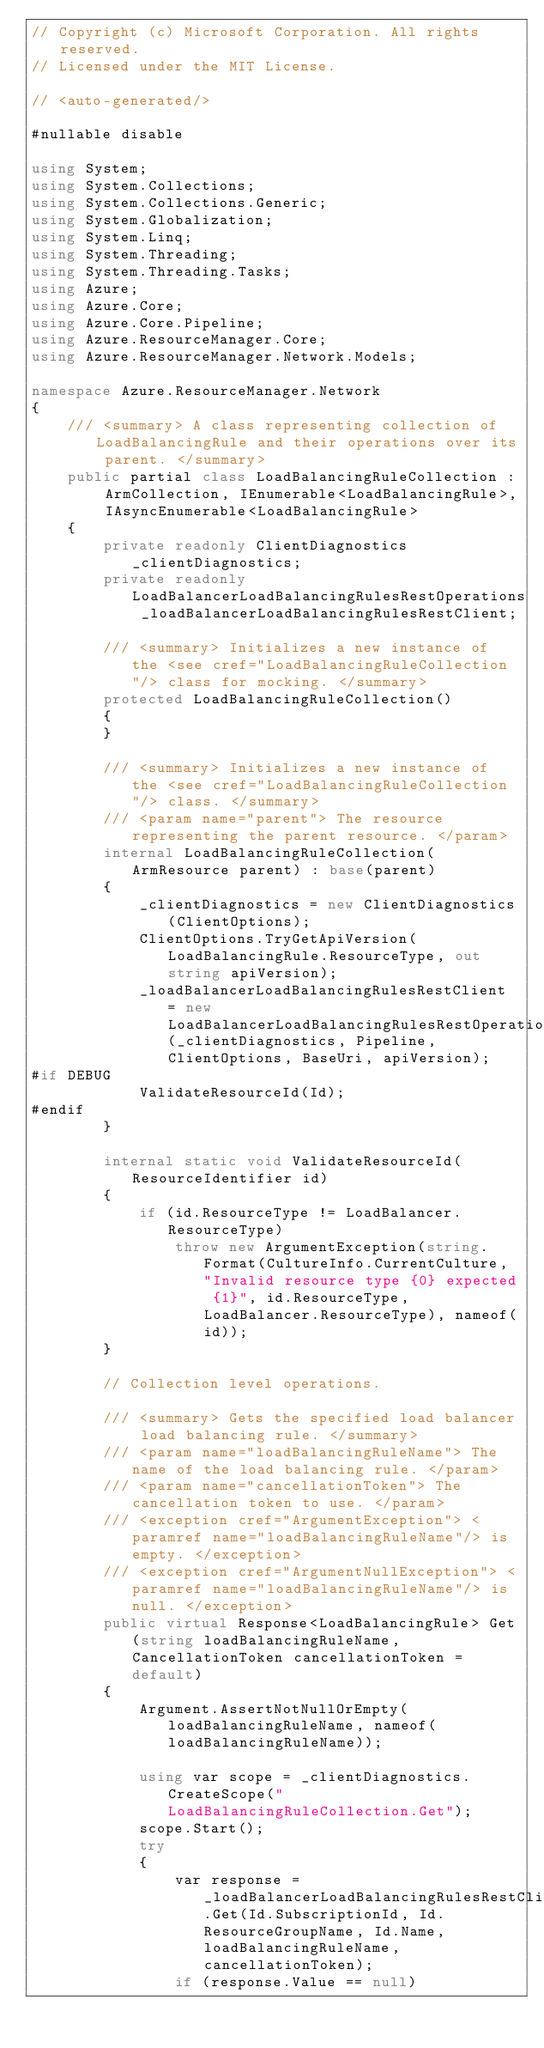<code> <loc_0><loc_0><loc_500><loc_500><_C#_>// Copyright (c) Microsoft Corporation. All rights reserved.
// Licensed under the MIT License.

// <auto-generated/>

#nullable disable

using System;
using System.Collections;
using System.Collections.Generic;
using System.Globalization;
using System.Linq;
using System.Threading;
using System.Threading.Tasks;
using Azure;
using Azure.Core;
using Azure.Core.Pipeline;
using Azure.ResourceManager.Core;
using Azure.ResourceManager.Network.Models;

namespace Azure.ResourceManager.Network
{
    /// <summary> A class representing collection of LoadBalancingRule and their operations over its parent. </summary>
    public partial class LoadBalancingRuleCollection : ArmCollection, IEnumerable<LoadBalancingRule>, IAsyncEnumerable<LoadBalancingRule>
    {
        private readonly ClientDiagnostics _clientDiagnostics;
        private readonly LoadBalancerLoadBalancingRulesRestOperations _loadBalancerLoadBalancingRulesRestClient;

        /// <summary> Initializes a new instance of the <see cref="LoadBalancingRuleCollection"/> class for mocking. </summary>
        protected LoadBalancingRuleCollection()
        {
        }

        /// <summary> Initializes a new instance of the <see cref="LoadBalancingRuleCollection"/> class. </summary>
        /// <param name="parent"> The resource representing the parent resource. </param>
        internal LoadBalancingRuleCollection(ArmResource parent) : base(parent)
        {
            _clientDiagnostics = new ClientDiagnostics(ClientOptions);
            ClientOptions.TryGetApiVersion(LoadBalancingRule.ResourceType, out string apiVersion);
            _loadBalancerLoadBalancingRulesRestClient = new LoadBalancerLoadBalancingRulesRestOperations(_clientDiagnostics, Pipeline, ClientOptions, BaseUri, apiVersion);
#if DEBUG
			ValidateResourceId(Id);
#endif
        }

        internal static void ValidateResourceId(ResourceIdentifier id)
        {
            if (id.ResourceType != LoadBalancer.ResourceType)
                throw new ArgumentException(string.Format(CultureInfo.CurrentCulture, "Invalid resource type {0} expected {1}", id.ResourceType, LoadBalancer.ResourceType), nameof(id));
        }

        // Collection level operations.

        /// <summary> Gets the specified load balancer load balancing rule. </summary>
        /// <param name="loadBalancingRuleName"> The name of the load balancing rule. </param>
        /// <param name="cancellationToken"> The cancellation token to use. </param>
        /// <exception cref="ArgumentException"> <paramref name="loadBalancingRuleName"/> is empty. </exception>
        /// <exception cref="ArgumentNullException"> <paramref name="loadBalancingRuleName"/> is null. </exception>
        public virtual Response<LoadBalancingRule> Get(string loadBalancingRuleName, CancellationToken cancellationToken = default)
        {
            Argument.AssertNotNullOrEmpty(loadBalancingRuleName, nameof(loadBalancingRuleName));

            using var scope = _clientDiagnostics.CreateScope("LoadBalancingRuleCollection.Get");
            scope.Start();
            try
            {
                var response = _loadBalancerLoadBalancingRulesRestClient.Get(Id.SubscriptionId, Id.ResourceGroupName, Id.Name, loadBalancingRuleName, cancellationToken);
                if (response.Value == null)</code> 